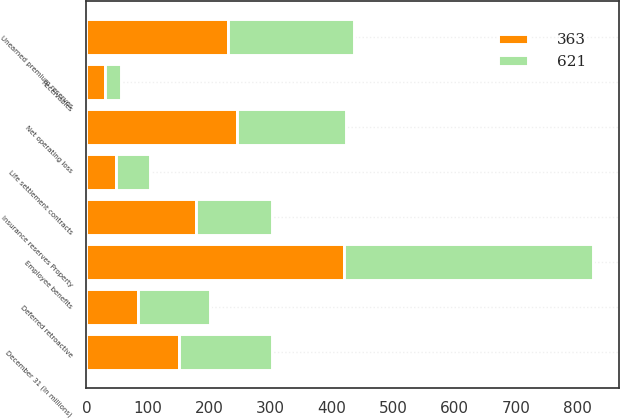<chart> <loc_0><loc_0><loc_500><loc_500><stacked_bar_chart><ecel><fcel>December 31 (In millions)<fcel>Insurance reserves Property<fcel>Unearned premium reserves<fcel>Receivables<fcel>Employee benefits<fcel>Life settlement contracts<fcel>Deferred retroactive<fcel>Net operating loss<nl><fcel>621<fcel>151.5<fcel>125<fcel>206<fcel>26<fcel>407<fcel>56<fcel>117<fcel>178<nl><fcel>363<fcel>151.5<fcel>178<fcel>230<fcel>30<fcel>419<fcel>48<fcel>84<fcel>245<nl></chart> 